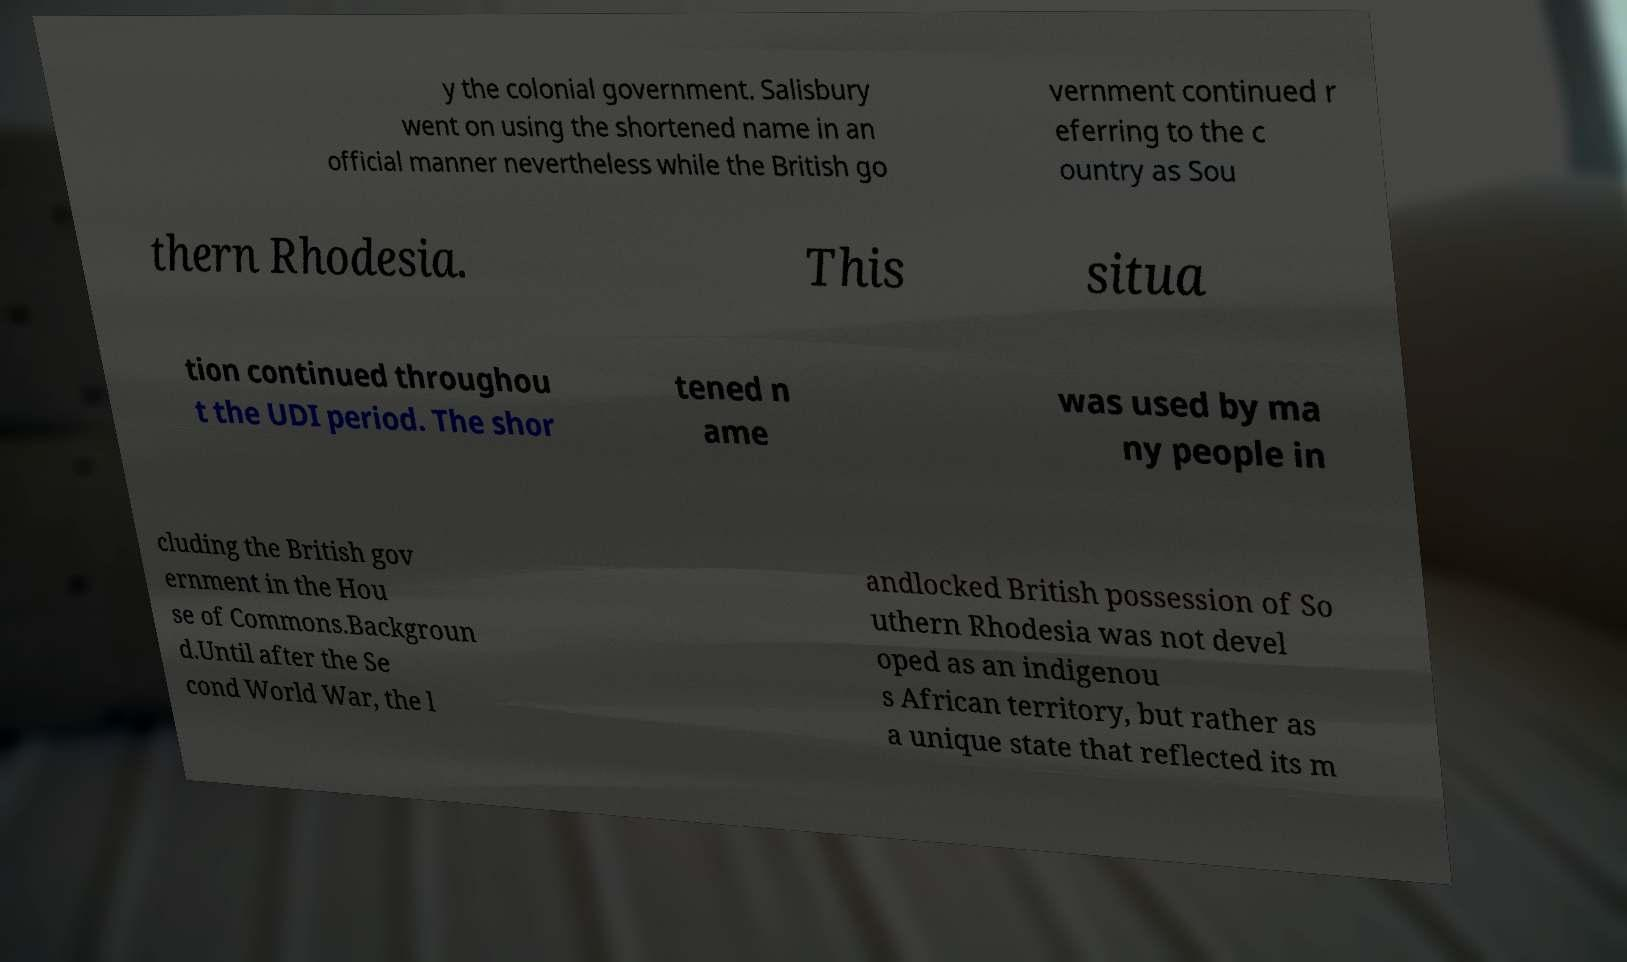Can you read and provide the text displayed in the image?This photo seems to have some interesting text. Can you extract and type it out for me? y the colonial government. Salisbury went on using the shortened name in an official manner nevertheless while the British go vernment continued r eferring to the c ountry as Sou thern Rhodesia. This situa tion continued throughou t the UDI period. The shor tened n ame was used by ma ny people in cluding the British gov ernment in the Hou se of Commons.Backgroun d.Until after the Se cond World War, the l andlocked British possession of So uthern Rhodesia was not devel oped as an indigenou s African territory, but rather as a unique state that reflected its m 